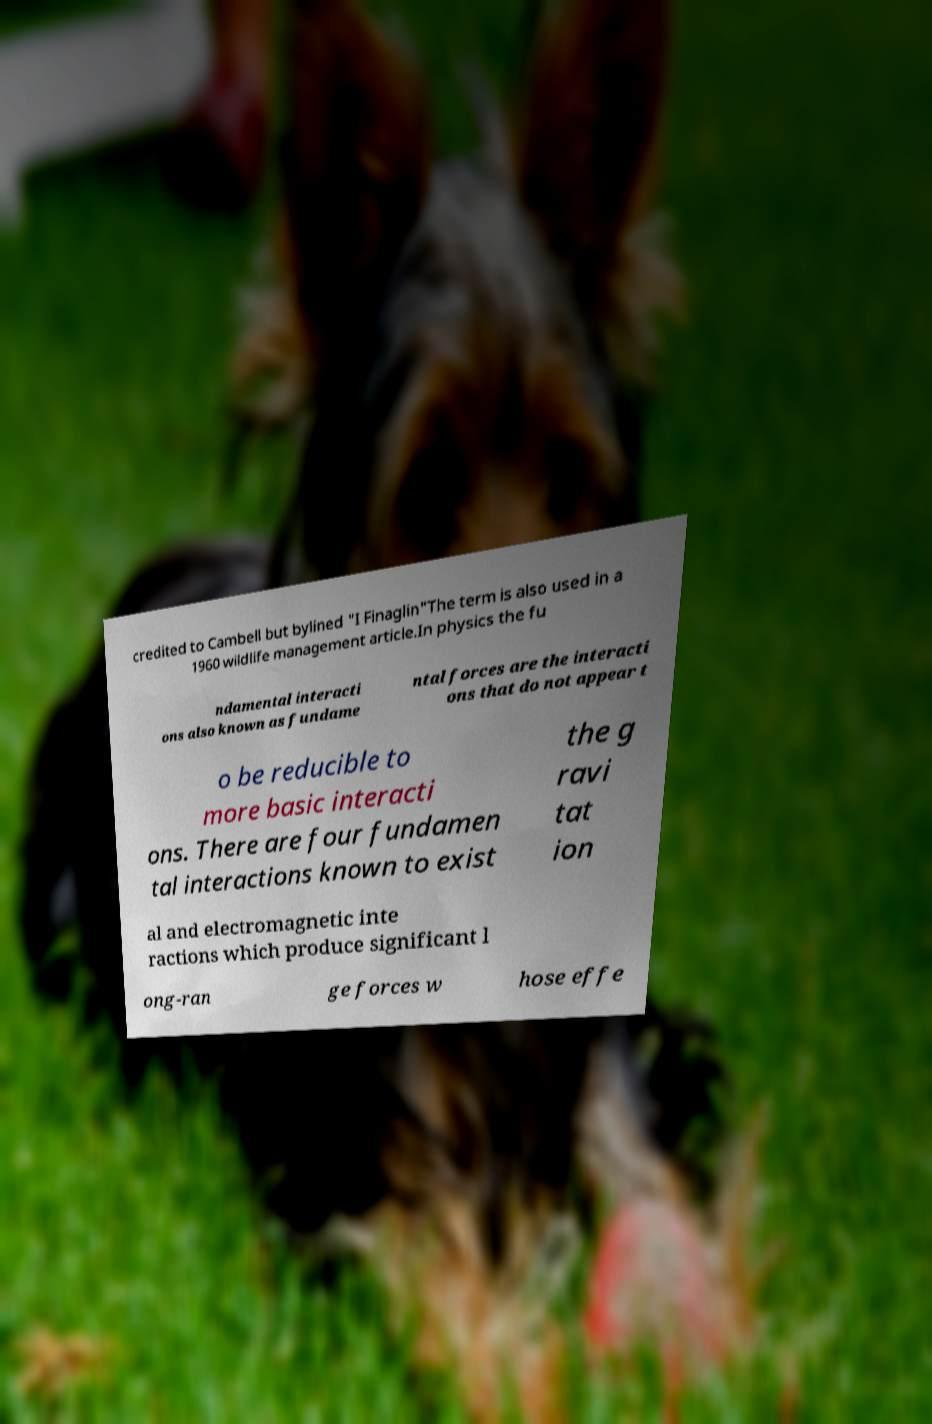Can you accurately transcribe the text from the provided image for me? credited to Cambell but bylined "I Finaglin"The term is also used in a 1960 wildlife management article.In physics the fu ndamental interacti ons also known as fundame ntal forces are the interacti ons that do not appear t o be reducible to more basic interacti ons. There are four fundamen tal interactions known to exist the g ravi tat ion al and electromagnetic inte ractions which produce significant l ong-ran ge forces w hose effe 